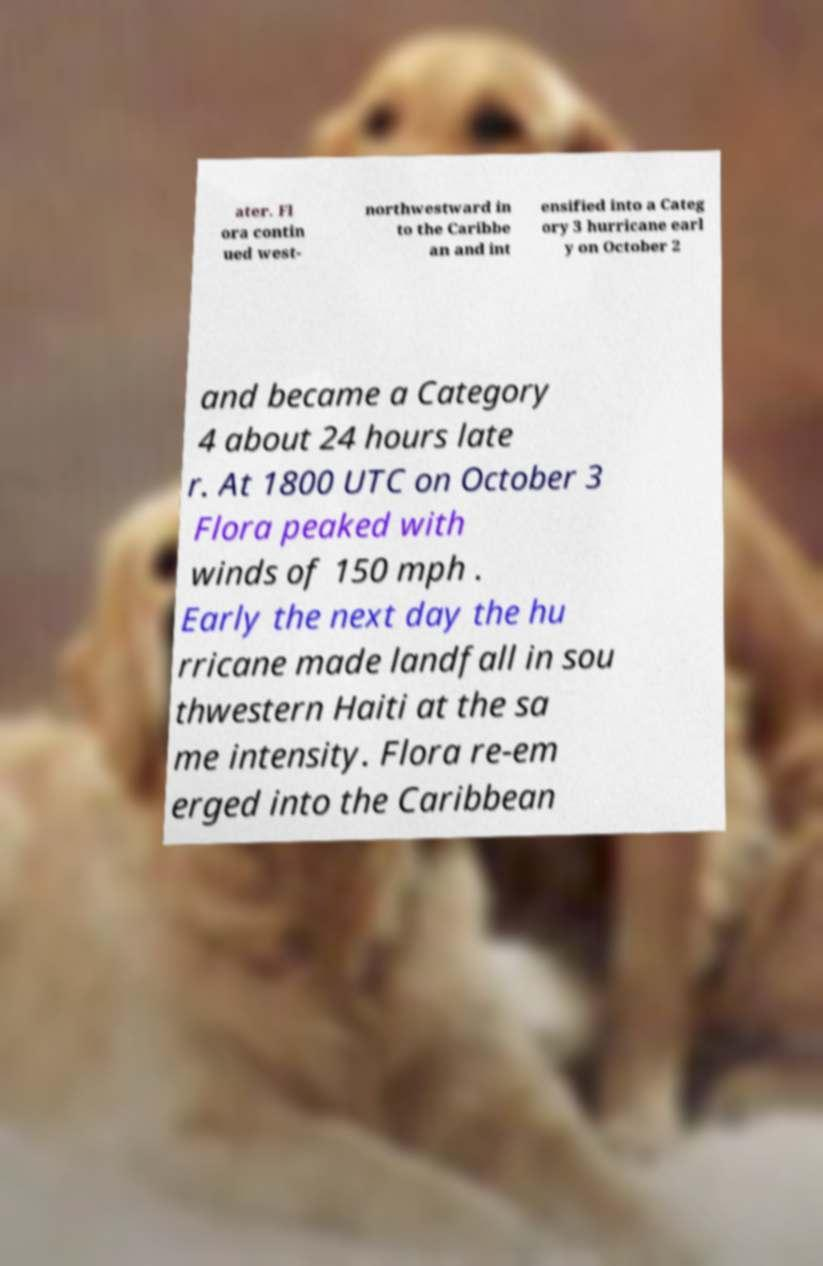For documentation purposes, I need the text within this image transcribed. Could you provide that? ater. Fl ora contin ued west- northwestward in to the Caribbe an and int ensified into a Categ ory 3 hurricane earl y on October 2 and became a Category 4 about 24 hours late r. At 1800 UTC on October 3 Flora peaked with winds of 150 mph . Early the next day the hu rricane made landfall in sou thwestern Haiti at the sa me intensity. Flora re-em erged into the Caribbean 